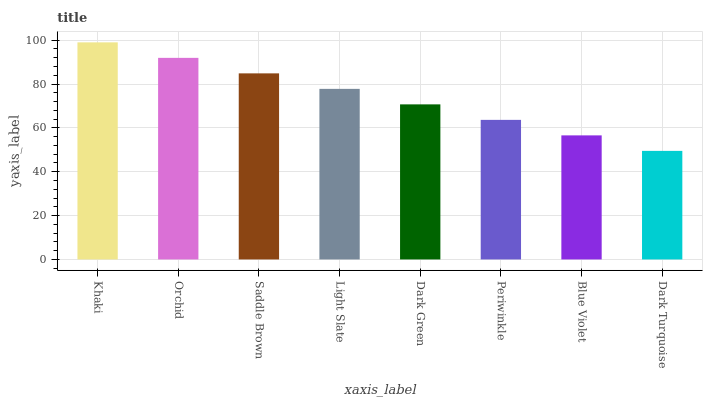Is Dark Turquoise the minimum?
Answer yes or no. Yes. Is Khaki the maximum?
Answer yes or no. Yes. Is Orchid the minimum?
Answer yes or no. No. Is Orchid the maximum?
Answer yes or no. No. Is Khaki greater than Orchid?
Answer yes or no. Yes. Is Orchid less than Khaki?
Answer yes or no. Yes. Is Orchid greater than Khaki?
Answer yes or no. No. Is Khaki less than Orchid?
Answer yes or no. No. Is Light Slate the high median?
Answer yes or no. Yes. Is Dark Green the low median?
Answer yes or no. Yes. Is Saddle Brown the high median?
Answer yes or no. No. Is Dark Turquoise the low median?
Answer yes or no. No. 